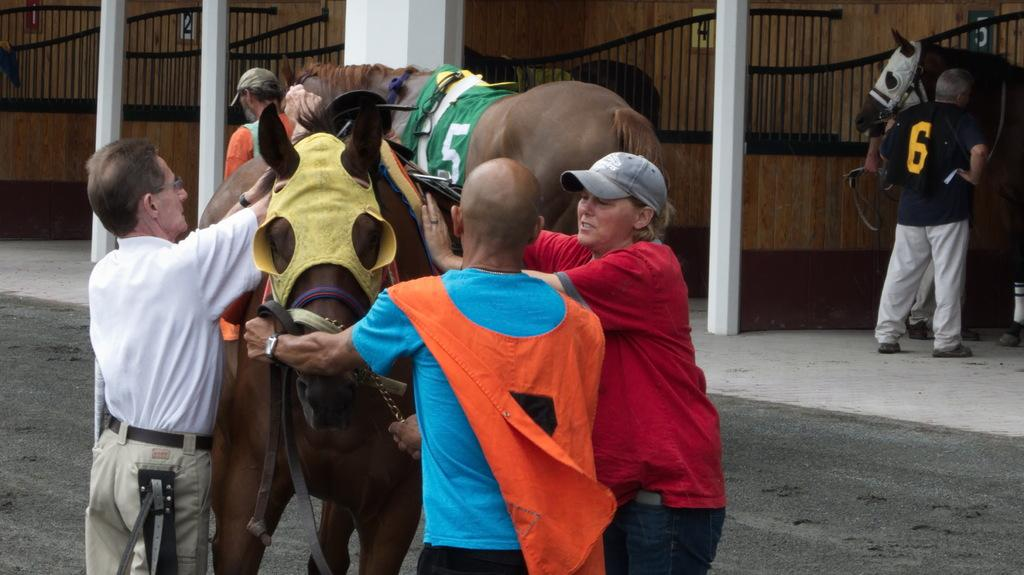How many people are in the image? There are three persons in the image. What are the three persons doing in the image? The three persons are holding a horse. What can be seen in the background of the image? There are horse stables in the background of the image. What is the belief of the horse in the image? The image does not depict the horse's beliefs, as it is an inanimate object and cannot have beliefs. 